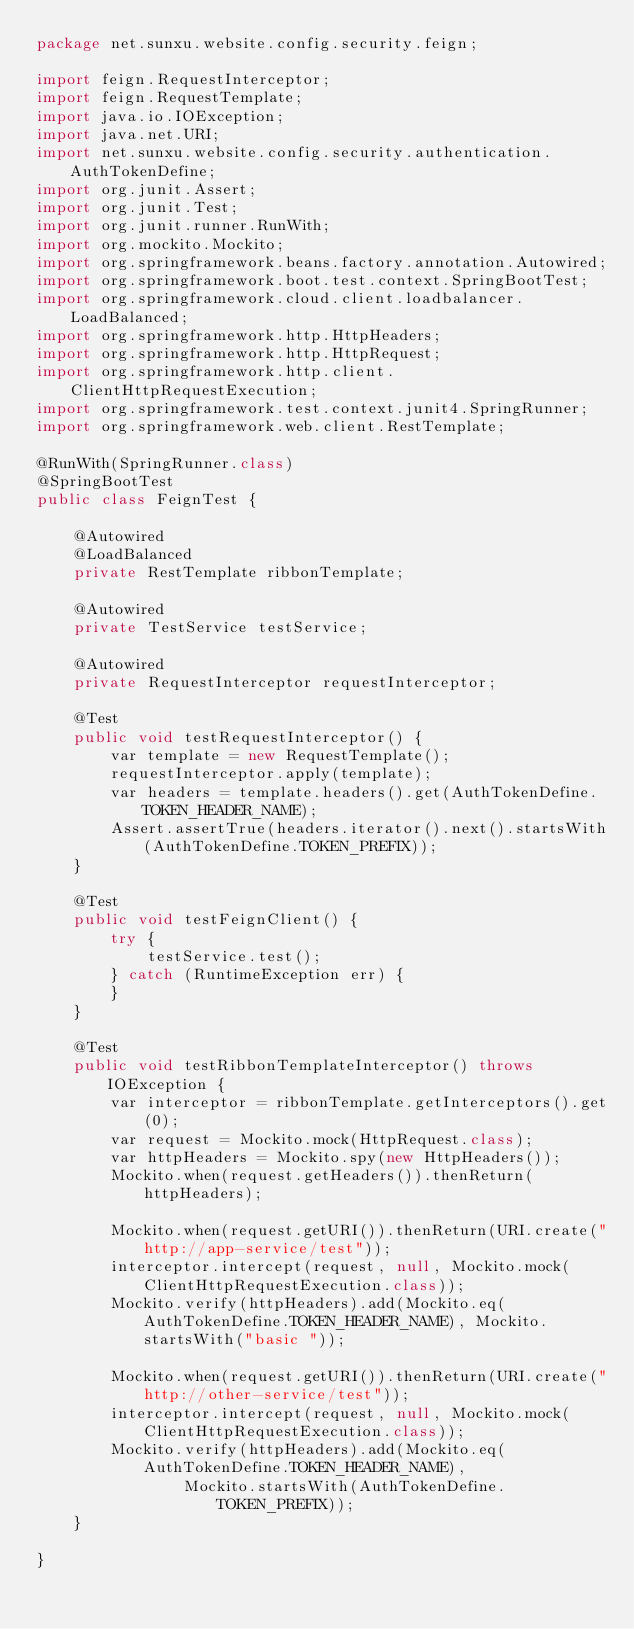Convert code to text. <code><loc_0><loc_0><loc_500><loc_500><_Java_>package net.sunxu.website.config.security.feign;

import feign.RequestInterceptor;
import feign.RequestTemplate;
import java.io.IOException;
import java.net.URI;
import net.sunxu.website.config.security.authentication.AuthTokenDefine;
import org.junit.Assert;
import org.junit.Test;
import org.junit.runner.RunWith;
import org.mockito.Mockito;
import org.springframework.beans.factory.annotation.Autowired;
import org.springframework.boot.test.context.SpringBootTest;
import org.springframework.cloud.client.loadbalancer.LoadBalanced;
import org.springframework.http.HttpHeaders;
import org.springframework.http.HttpRequest;
import org.springframework.http.client.ClientHttpRequestExecution;
import org.springframework.test.context.junit4.SpringRunner;
import org.springframework.web.client.RestTemplate;

@RunWith(SpringRunner.class)
@SpringBootTest
public class FeignTest {

    @Autowired
    @LoadBalanced
    private RestTemplate ribbonTemplate;

    @Autowired
    private TestService testService;

    @Autowired
    private RequestInterceptor requestInterceptor;

    @Test
    public void testRequestInterceptor() {
        var template = new RequestTemplate();
        requestInterceptor.apply(template);
        var headers = template.headers().get(AuthTokenDefine.TOKEN_HEADER_NAME);
        Assert.assertTrue(headers.iterator().next().startsWith(AuthTokenDefine.TOKEN_PREFIX));
    }

    @Test
    public void testFeignClient() {
        try {
            testService.test();
        } catch (RuntimeException err) {
        }
    }

    @Test
    public void testRibbonTemplateInterceptor() throws IOException {
        var interceptor = ribbonTemplate.getInterceptors().get(0);
        var request = Mockito.mock(HttpRequest.class);
        var httpHeaders = Mockito.spy(new HttpHeaders());
        Mockito.when(request.getHeaders()).thenReturn(httpHeaders);

        Mockito.when(request.getURI()).thenReturn(URI.create("http://app-service/test"));
        interceptor.intercept(request, null, Mockito.mock(ClientHttpRequestExecution.class));
        Mockito.verify(httpHeaders).add(Mockito.eq(AuthTokenDefine.TOKEN_HEADER_NAME), Mockito.startsWith("basic "));

        Mockito.when(request.getURI()).thenReturn(URI.create("http://other-service/test"));
        interceptor.intercept(request, null, Mockito.mock(ClientHttpRequestExecution.class));
        Mockito.verify(httpHeaders).add(Mockito.eq(AuthTokenDefine.TOKEN_HEADER_NAME),
                Mockito.startsWith(AuthTokenDefine.TOKEN_PREFIX));
    }

}
</code> 